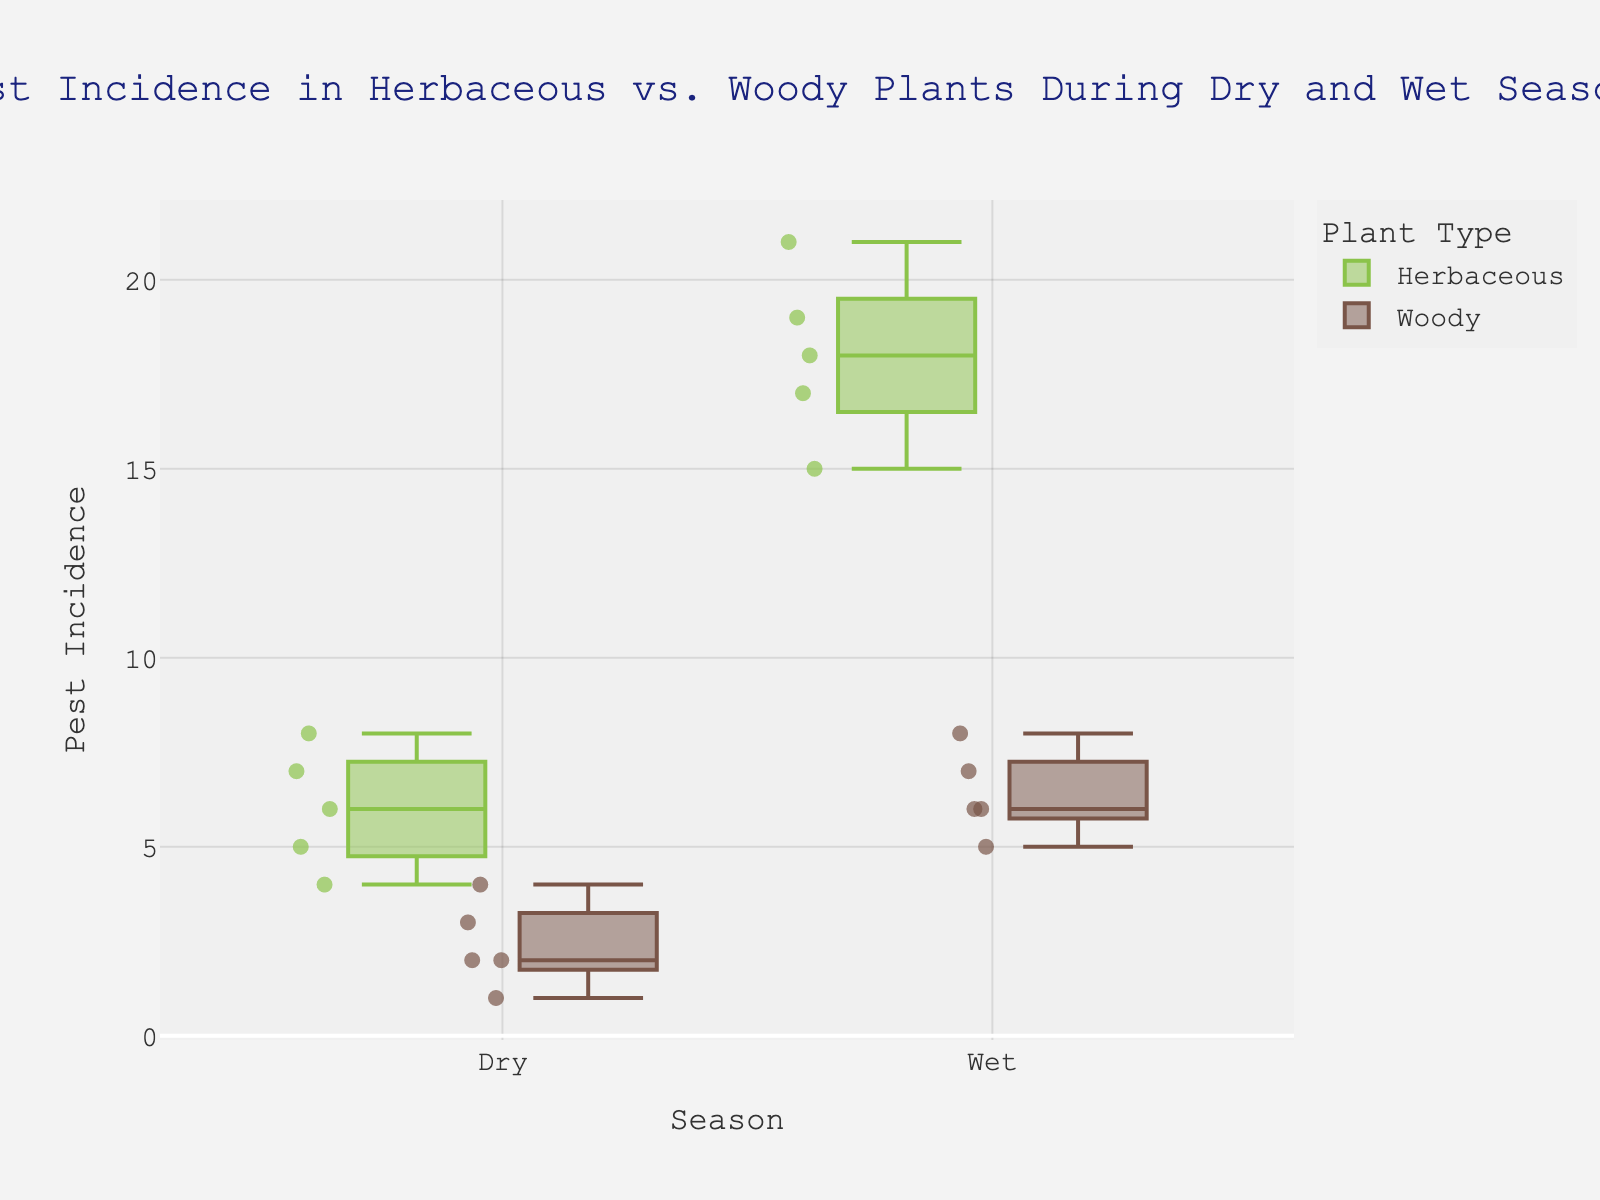What's the title of the figure? The title of the figure is usually located at the top and highlights the main focus or comparison being shown in the plot.
Answer: Pest Incidence in Herbaceous vs. Woody Plants During Dry and Wet Seasons What are the two seasons compared in the plot? The x-axis labels on the figure show the categories of seasons being compared.
Answer: Dry and Wet Which plant type shows higher pest incidence during the dry season? By looking at the box plots for the dry season, compare the medians or overall position of Herbaceous and Woody plants.
Answer: Herbaceous How many data points are there for Woody plants during the wet season? Count the number of individual data points (dots) present in the box plot for Woody plants in the wet season.
Answer: 5 What is the range of pest incidence in Herbaceous plants during the wet season? The range is determined by subtracting the minimum value from the maximum value of the box plot for Herbaceous plants during the wet season.
Answer: 6 (21–15) What is the median pest incidence for Woody plants during the dry season? The median is represented by the line inside the box for Woody plants in the dry season.
Answer: 2 Compare the interquartile range (IQR) for Herbaceous plants in both dry and wet seasons. The IQR is the difference between the 25th percentile (bottom of the box) and the 75th percentile (top of the box) for Herbaceous plants in both seasons. Calculate this for dry (IQR = 7-5 = 2) and wet (IQR = 18-17 = 1) seasons, then compare.
Answer: Dry: 2, Wet: 1 Do the Herbaceous plants or Woody plants show a greater increase in pest incidence from the dry to the wet season? Calculate the difference in median pest incidence for both Herbaceous (19-6 = 13) and Woody plants (6-2 = 4), then compare which increase is greater.
Answer: Herbaceous Which group of plants has the lowest pest incidence reported in any season? Look for the lowest data point among all box plots in the figure.
Answer: Woody (1 in dry season) 